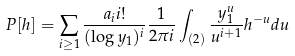Convert formula to latex. <formula><loc_0><loc_0><loc_500><loc_500>P [ h ] = \sum _ { i \geq 1 } \frac { a _ { i } i ! } { ( \log y _ { 1 } ) ^ { i } } \frac { 1 } { 2 \pi i } \int _ { ( 2 ) } \frac { y _ { 1 } ^ { u } } { u ^ { i + 1 } } h ^ { - u } d u</formula> 